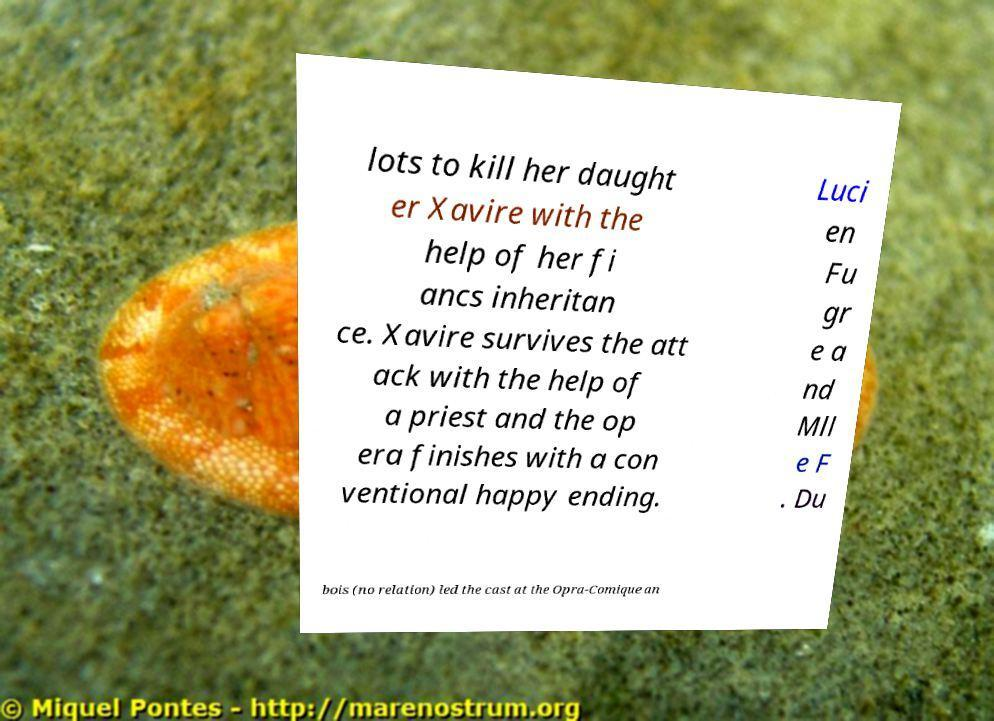I need the written content from this picture converted into text. Can you do that? lots to kill her daught er Xavire with the help of her fi ancs inheritan ce. Xavire survives the att ack with the help of a priest and the op era finishes with a con ventional happy ending. Luci en Fu gr e a nd Mll e F . Du bois (no relation) led the cast at the Opra-Comique an 